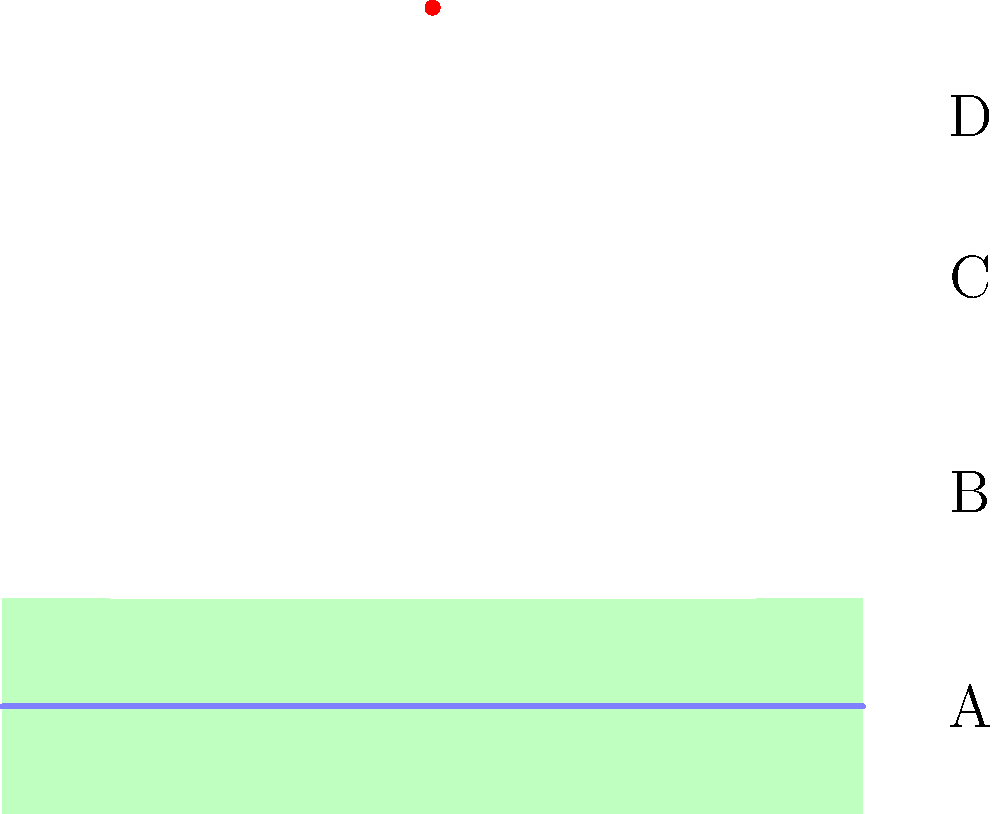In traditional Italian wedding cakes, which tier typically features the "confetti" (sugar-coated almonds) as a symbol of good luck and fertility? To answer this question, let's consider the structure and symbolism of traditional Italian wedding cakes:

1. Italian wedding cakes, known as "Millefoglie" or "Torta Nuziale," are typically multi-tiered.

2. The cake is usually composed of several layers, each with its own significance:
   A. The base tier is often the largest and serves as the foundation.
   B. The middle tiers add height and visual appeal.
   C. The top tier is traditionally the smallest.

3. "Confetti" (sugar-coated almonds) play a crucial role in Italian weddings:
   - They symbolize good luck, fertility, and prosperity.
   - The bitter almond and sweet coating represent the bittersweet nature of marriage.

4. In traditional Italian wedding customs, the "confetti" are typically placed on or around the top tier of the cake.

5. The top tier (labeled D in the image) is often reserved for special decorations or symbolic elements.

Therefore, based on Italian wedding traditions and cake design customs, the "confetti" would most likely be featured on the top tier of the cake.
Answer: Top tier (D) 